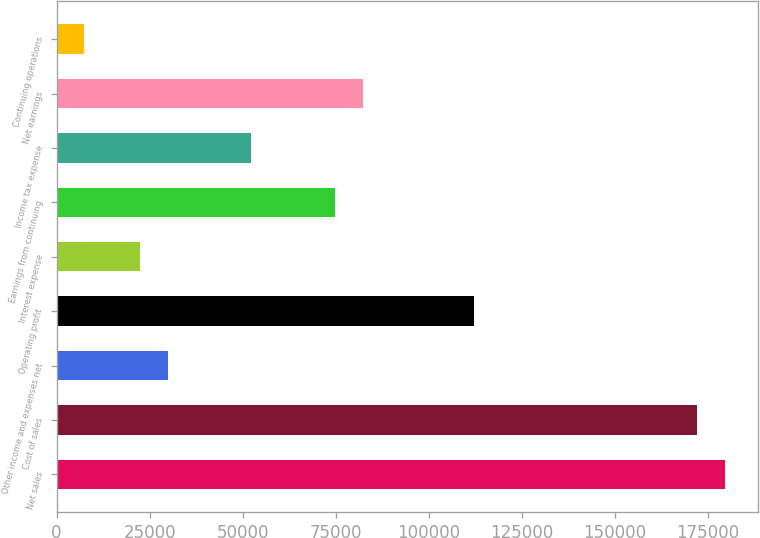Convert chart to OTSL. <chart><loc_0><loc_0><loc_500><loc_500><bar_chart><fcel>Net sales<fcel>Cost of sales<fcel>Other income and expenses net<fcel>Operating profit<fcel>Interest expense<fcel>Earnings from continuing<fcel>Income tax expense<fcel>Net earnings<fcel>Continuing operations<nl><fcel>179578<fcel>172096<fcel>29930.7<fcel>112237<fcel>22448.2<fcel>74825<fcel>52377.8<fcel>82307.4<fcel>7483.45<nl></chart> 